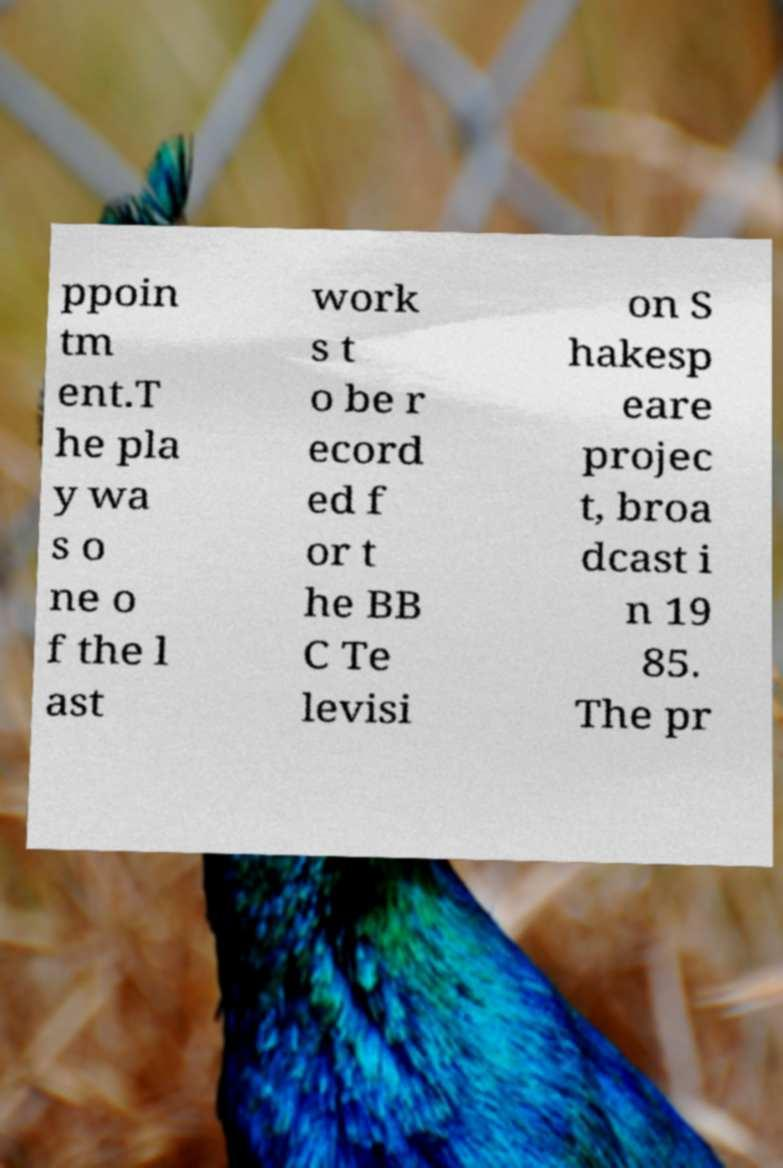I need the written content from this picture converted into text. Can you do that? ppoin tm ent.T he pla y wa s o ne o f the l ast work s t o be r ecord ed f or t he BB C Te levisi on S hakesp eare projec t, broa dcast i n 19 85. The pr 